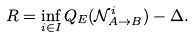Convert formula to latex. <formula><loc_0><loc_0><loc_500><loc_500>R = \inf _ { i \in I } Q _ { E } ( \mathcal { N } ^ { i } _ { A \to B } ) - \Delta .</formula> 